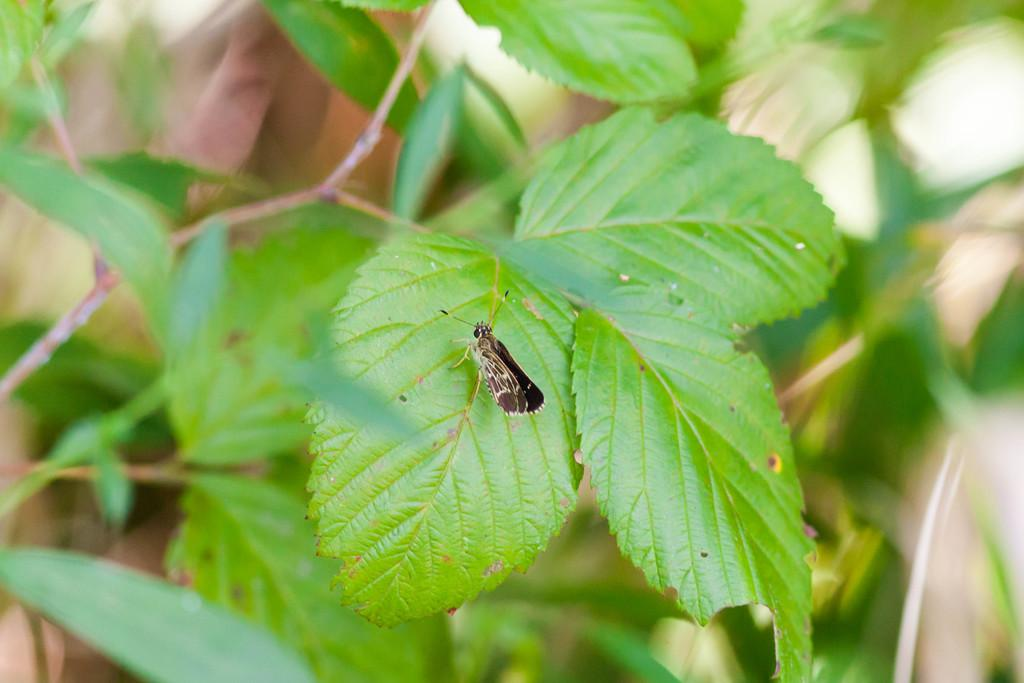What type of living organism can be seen in the picture? There is a plant in the picture. What other living organism can be seen in the picture? There is an insect in the center of the picture. What mode of transport is the insect using in the picture? There is no mode of transport visible in the picture; the insect is simply located in the center of the image. 